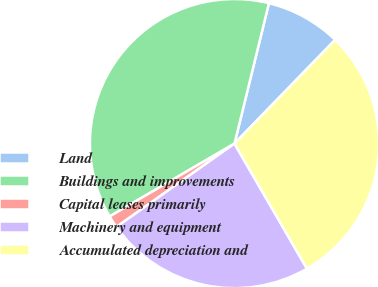Convert chart. <chart><loc_0><loc_0><loc_500><loc_500><pie_chart><fcel>Land<fcel>Buildings and improvements<fcel>Capital leases primarily<fcel>Machinery and equipment<fcel>Accumulated depreciation and<nl><fcel>8.43%<fcel>37.23%<fcel>1.38%<fcel>23.57%<fcel>29.38%<nl></chart> 